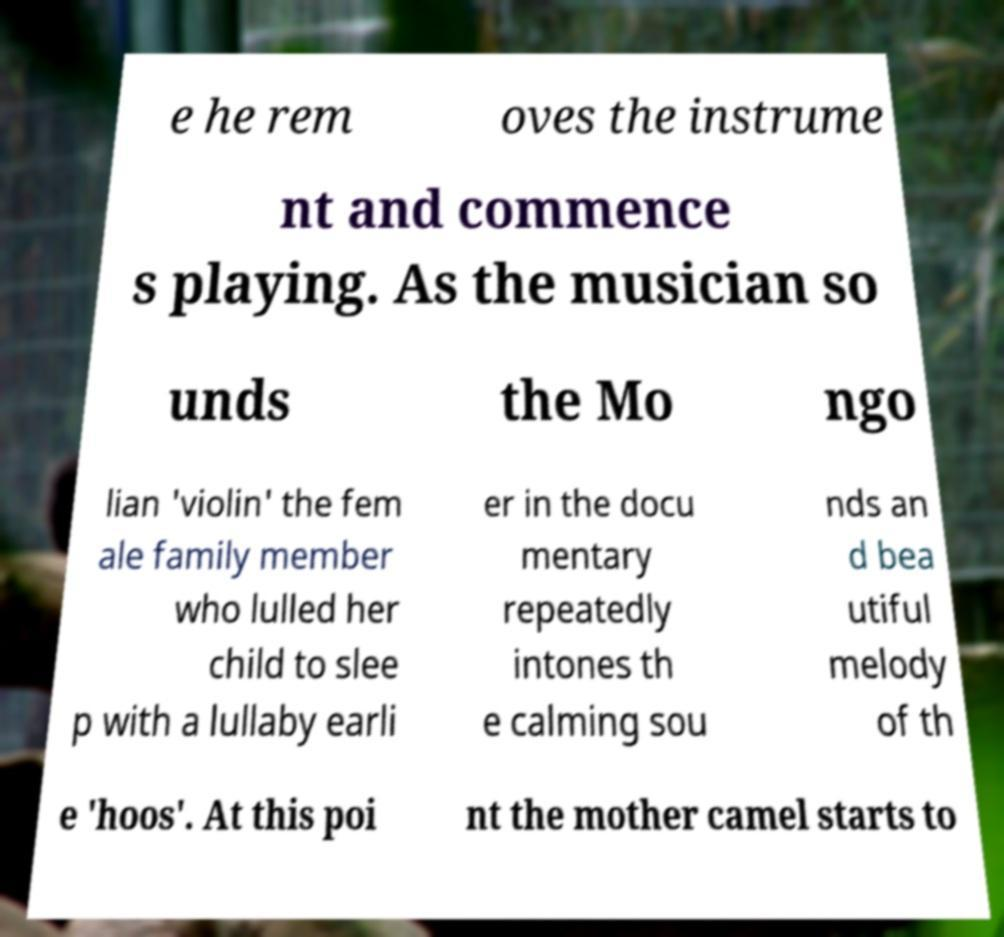Please read and relay the text visible in this image. What does it say? e he rem oves the instrume nt and commence s playing. As the musician so unds the Mo ngo lian 'violin' the fem ale family member who lulled her child to slee p with a lullaby earli er in the docu mentary repeatedly intones th e calming sou nds an d bea utiful melody of th e 'hoos'. At this poi nt the mother camel starts to 